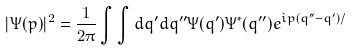Convert formula to latex. <formula><loc_0><loc_0><loc_500><loc_500>| \Psi ( p ) | ^ { 2 } = \frac { 1 } { 2 \pi } \int \int d q ^ { \prime } d q ^ { \prime \prime } \Psi ( q ^ { \prime } ) \Psi ^ { * } ( q ^ { \prime \prime } ) e ^ { i p ( q ^ { \prime \prime } - q ^ { \prime } ) / }</formula> 